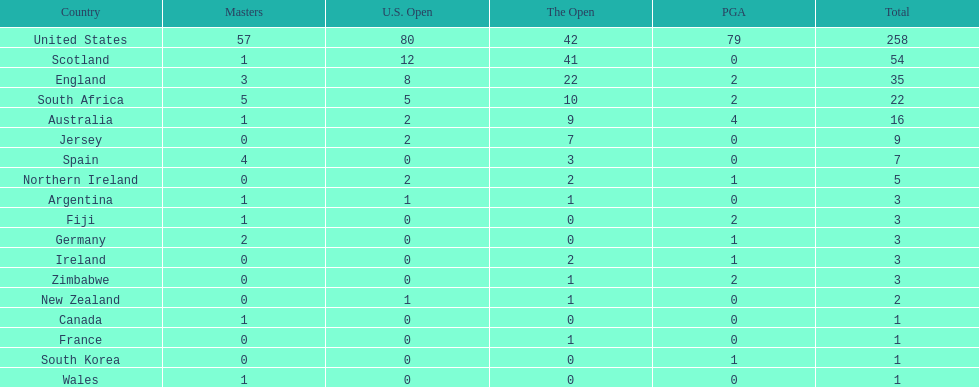How many nations have generated an equal amount of championship golfers as canada? 3. 